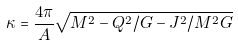<formula> <loc_0><loc_0><loc_500><loc_500>\kappa = \frac { 4 \pi } { A } \sqrt { M ^ { 2 } - Q ^ { 2 } / G - J ^ { 2 } / M ^ { 2 } G }</formula> 